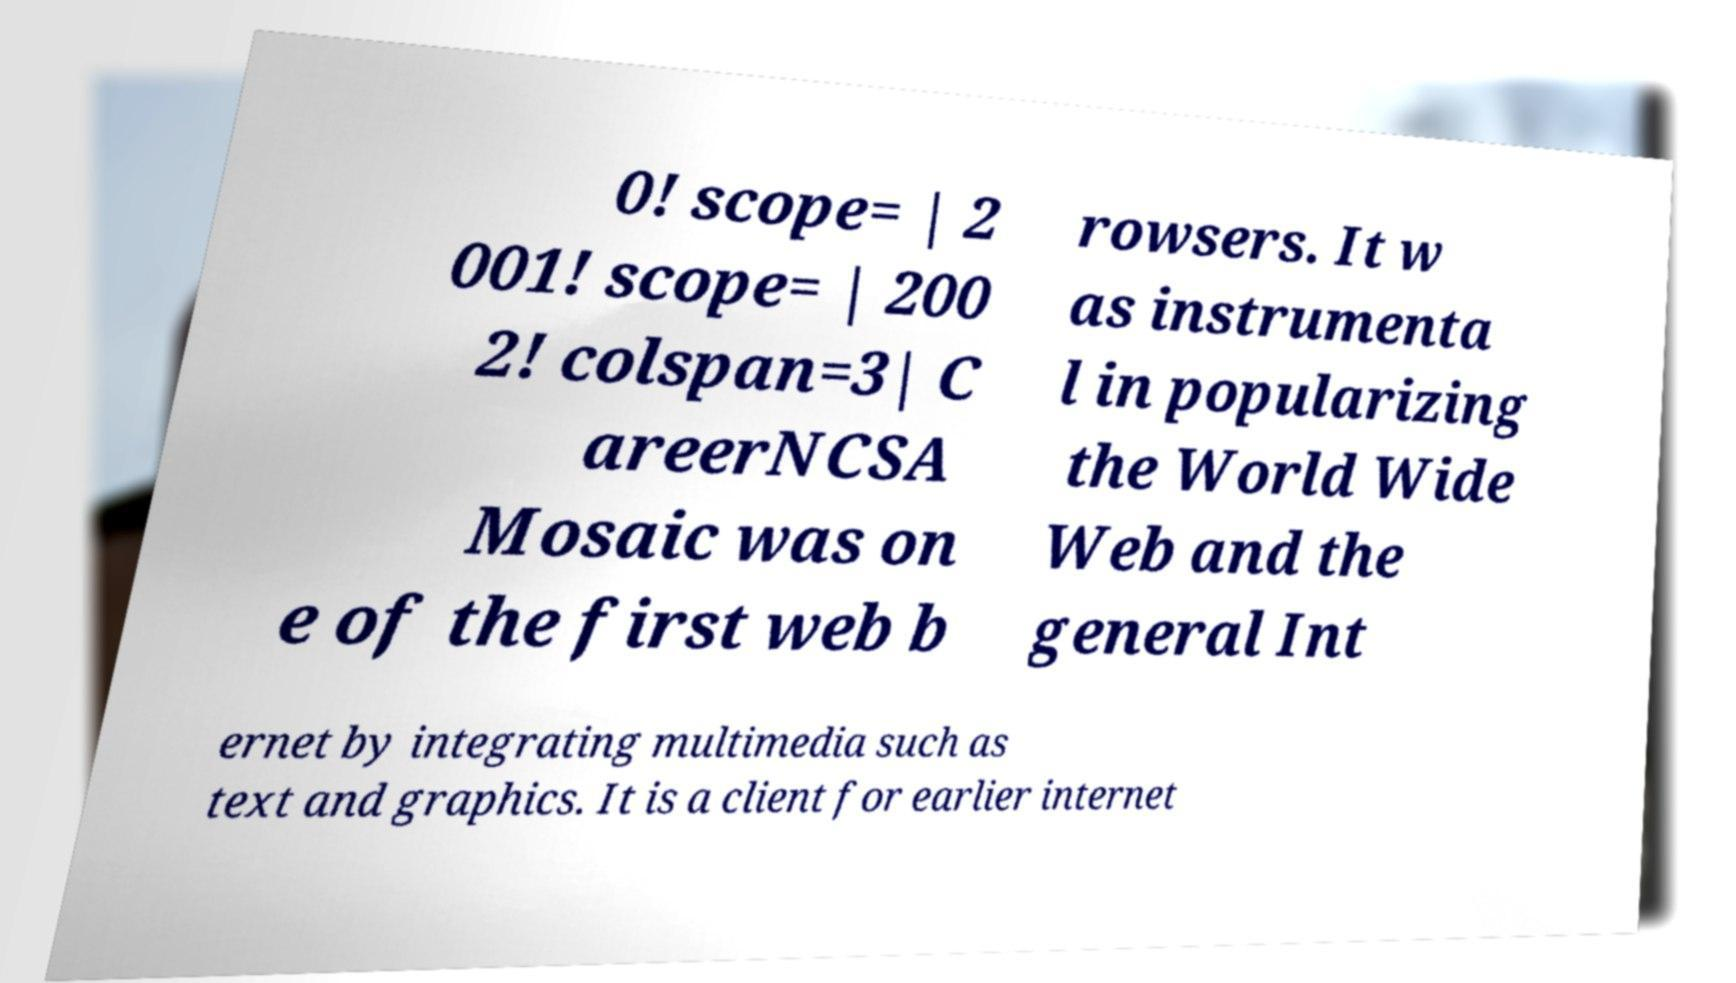I need the written content from this picture converted into text. Can you do that? 0! scope= | 2 001! scope= | 200 2! colspan=3| C areerNCSA Mosaic was on e of the first web b rowsers. It w as instrumenta l in popularizing the World Wide Web and the general Int ernet by integrating multimedia such as text and graphics. It is a client for earlier internet 